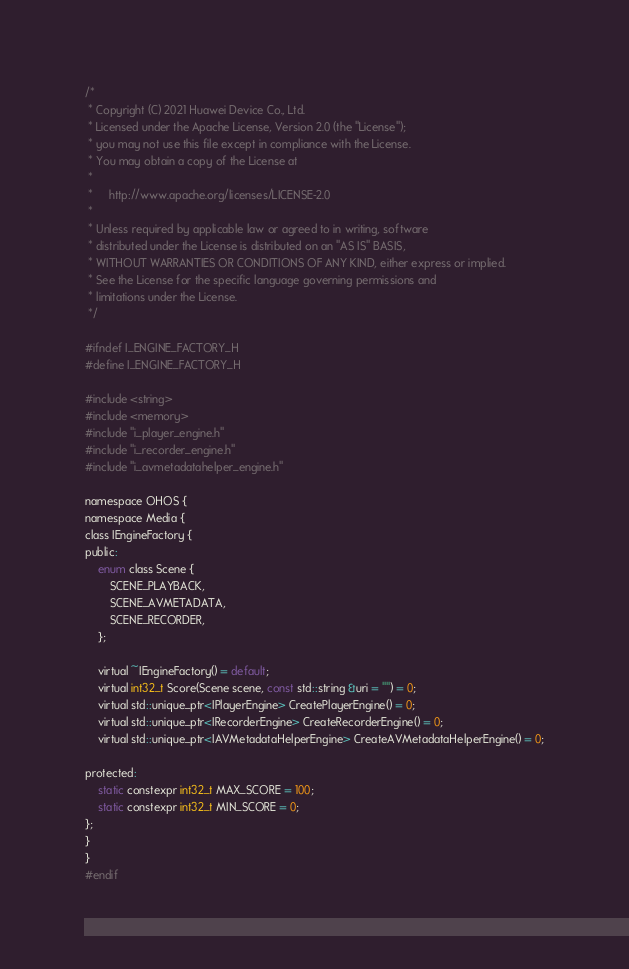Convert code to text. <code><loc_0><loc_0><loc_500><loc_500><_C_>/*
 * Copyright (C) 2021 Huawei Device Co., Ltd.
 * Licensed under the Apache License, Version 2.0 (the "License");
 * you may not use this file except in compliance with the License.
 * You may obtain a copy of the License at
 *
 *     http://www.apache.org/licenses/LICENSE-2.0
 *
 * Unless required by applicable law or agreed to in writing, software
 * distributed under the License is distributed on an "AS IS" BASIS,
 * WITHOUT WARRANTIES OR CONDITIONS OF ANY KIND, either express or implied.
 * See the License for the specific language governing permissions and
 * limitations under the License.
 */

#ifndef I_ENGINE_FACTORY_H
#define I_ENGINE_FACTORY_H

#include <string>
#include <memory>
#include "i_player_engine.h"
#include "i_recorder_engine.h"
#include "i_avmetadatahelper_engine.h"

namespace OHOS {
namespace Media {
class IEngineFactory {
public:
    enum class Scene {
        SCENE_PLAYBACK,
        SCENE_AVMETADATA,
        SCENE_RECORDER,
    };

    virtual ~IEngineFactory() = default;
    virtual int32_t Score(Scene scene, const std::string &uri = "") = 0;
    virtual std::unique_ptr<IPlayerEngine> CreatePlayerEngine() = 0;
    virtual std::unique_ptr<IRecorderEngine> CreateRecorderEngine() = 0;
    virtual std::unique_ptr<IAVMetadataHelperEngine> CreateAVMetadataHelperEngine() = 0;

protected:
    static constexpr int32_t MAX_SCORE = 100;
    static constexpr int32_t MIN_SCORE = 0;
};
}
}
#endif</code> 